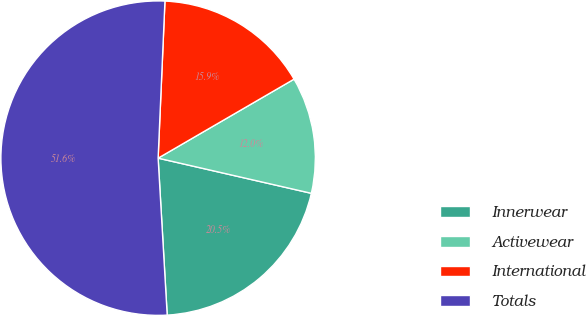Convert chart to OTSL. <chart><loc_0><loc_0><loc_500><loc_500><pie_chart><fcel>Innerwear<fcel>Activewear<fcel>International<fcel>Totals<nl><fcel>20.49%<fcel>11.97%<fcel>15.93%<fcel>51.61%<nl></chart> 